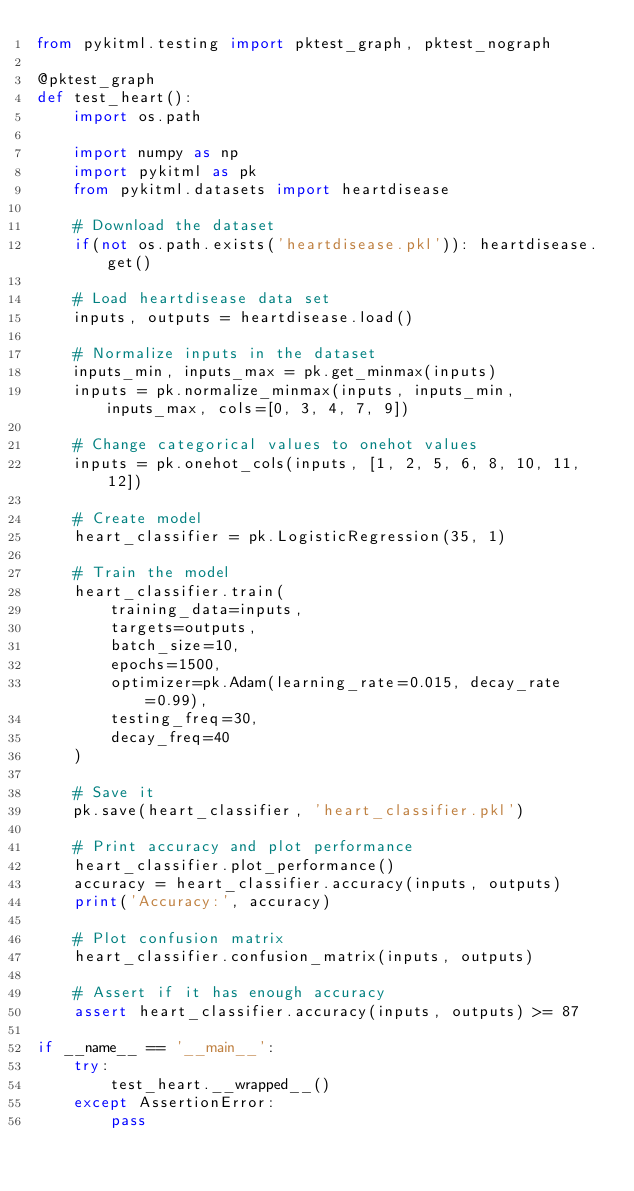<code> <loc_0><loc_0><loc_500><loc_500><_Python_>from pykitml.testing import pktest_graph, pktest_nograph

@pktest_graph
def test_heart():
    import os.path

    import numpy as np
    import pykitml as pk
    from pykitml.datasets import heartdisease

    # Download the dataset 
    if(not os.path.exists('heartdisease.pkl')): heartdisease.get()

    # Load heartdisease data set
    inputs, outputs = heartdisease.load()

    # Normalize inputs in the dataset
    inputs_min, inputs_max = pk.get_minmax(inputs)
    inputs = pk.normalize_minmax(inputs, inputs_min, inputs_max, cols=[0, 3, 4, 7, 9])  

    # Change categorical values to onehot values
    inputs = pk.onehot_cols(inputs, [1, 2, 5, 6, 8, 10, 11, 12])      

    # Create model
    heart_classifier = pk.LogisticRegression(35, 1)

    # Train the model
    heart_classifier.train(
        training_data=inputs,
        targets=outputs, 
        batch_size=10, 
        epochs=1500, 
        optimizer=pk.Adam(learning_rate=0.015, decay_rate=0.99), 
        testing_freq=30,
        decay_freq=40
    )

    # Save it
    pk.save(heart_classifier, 'heart_classifier.pkl') 

    # Print accuracy and plot performance
    heart_classifier.plot_performance()
    accuracy = heart_classifier.accuracy(inputs, outputs)
    print('Accuracy:', accuracy)

    # Plot confusion matrix
    heart_classifier.confusion_matrix(inputs, outputs)

    # Assert if it has enough accuracy
    assert heart_classifier.accuracy(inputs, outputs) >= 87

if __name__ == '__main__':
    try:
        test_heart.__wrapped__()
    except AssertionError:
        pass</code> 